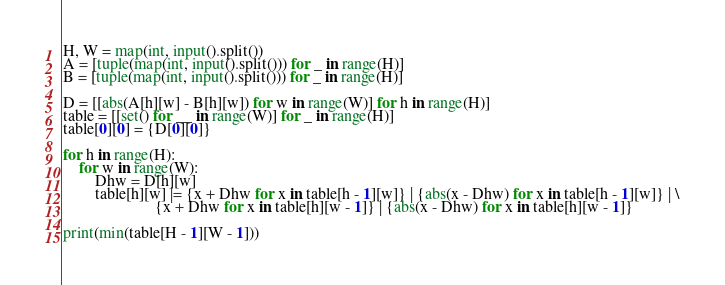Convert code to text. <code><loc_0><loc_0><loc_500><loc_500><_Python_>H, W = map(int, input().split())
A = [tuple(map(int, input().split())) for _ in range(H)]
B = [tuple(map(int, input().split())) for _ in range(H)]

D = [[abs(A[h][w] - B[h][w]) for w in range(W)] for h in range(H)]
table = [[set() for __ in range(W)] for _ in range(H)]
table[0][0] = {D[0][0]}

for h in range(H):
    for w in range(W):
        Dhw = D[h][w]
        table[h][w] |= {x + Dhw for x in table[h - 1][w]} | {abs(x - Dhw) for x in table[h - 1][w]} | \
                       {x + Dhw for x in table[h][w - 1]} | {abs(x - Dhw) for x in table[h][w - 1]}

print(min(table[H - 1][W - 1]))
</code> 